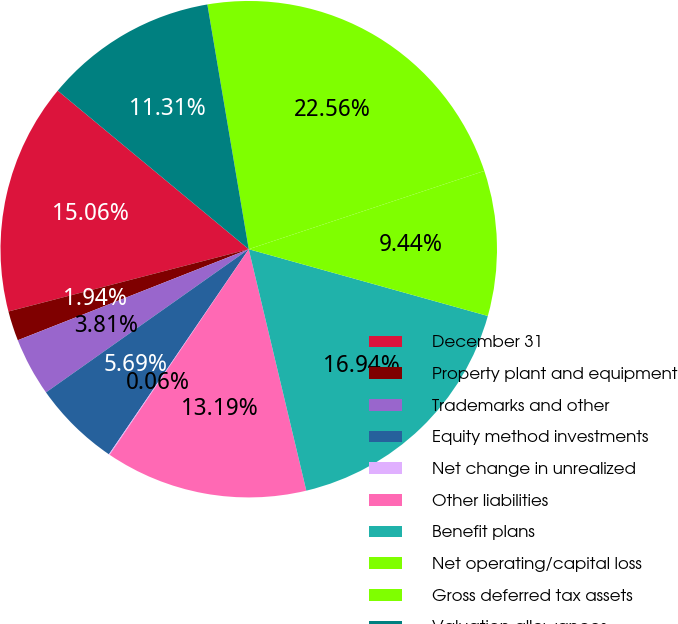Convert chart. <chart><loc_0><loc_0><loc_500><loc_500><pie_chart><fcel>December 31<fcel>Property plant and equipment<fcel>Trademarks and other<fcel>Equity method investments<fcel>Net change in unrealized<fcel>Other liabilities<fcel>Benefit plans<fcel>Net operating/capital loss<fcel>Gross deferred tax assets<fcel>Valuation allowances<nl><fcel>15.06%<fcel>1.94%<fcel>3.81%<fcel>5.69%<fcel>0.06%<fcel>13.19%<fcel>16.94%<fcel>9.44%<fcel>22.56%<fcel>11.31%<nl></chart> 